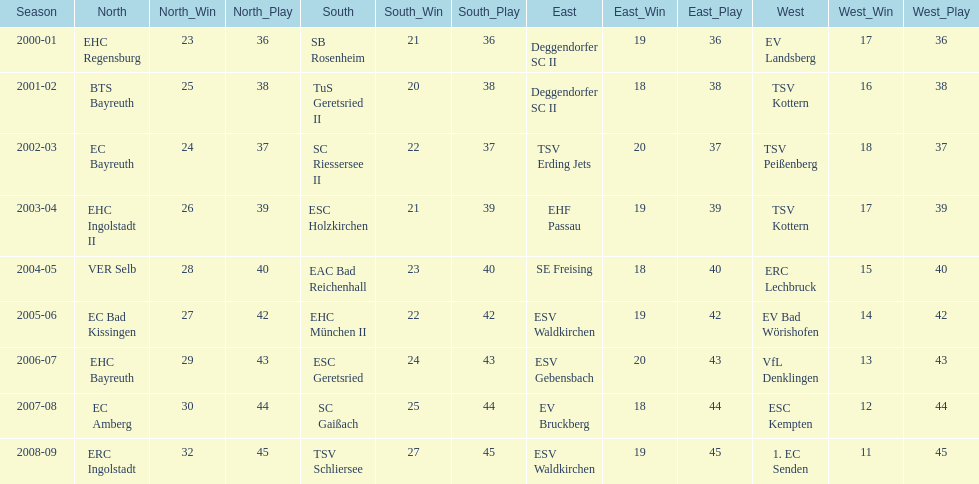Which team emerged victorious in the northern season prior to ec bayreuth's win in 2002-03? BTS Bayreuth. 